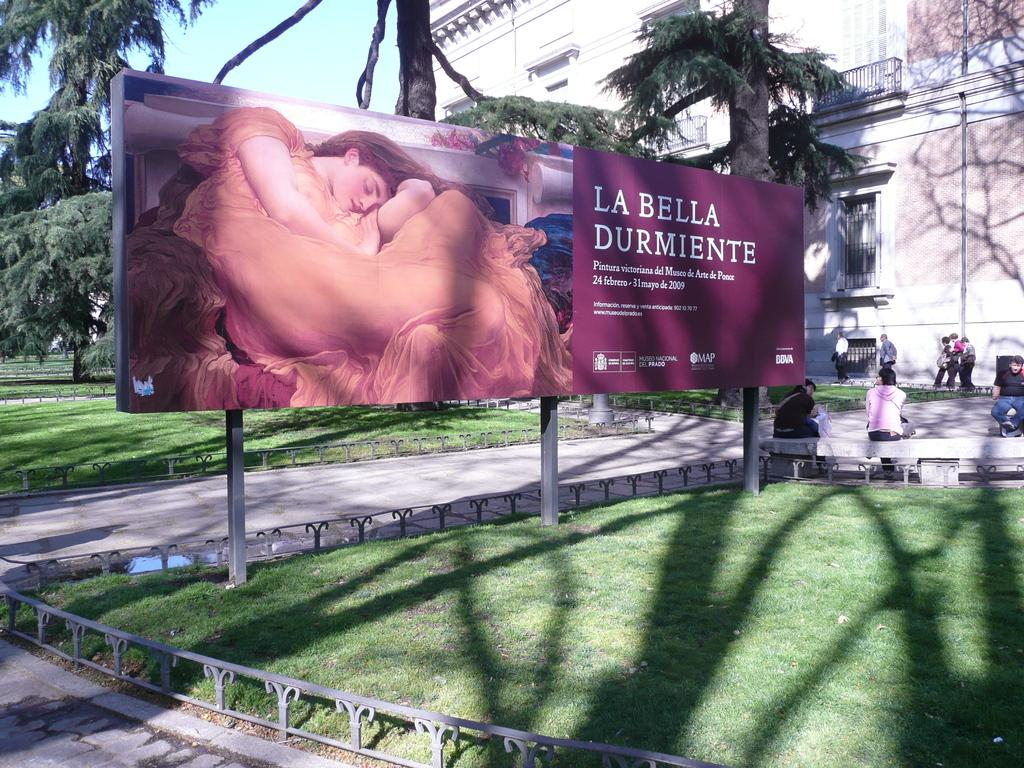<image>
Give a short and clear explanation of the subsequent image. A large billboard the reads La Bella Durmiente and a woman in orange on it. 